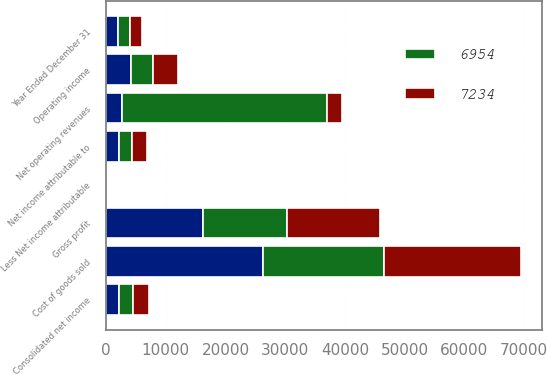Convert chart to OTSL. <chart><loc_0><loc_0><loc_500><loc_500><stacked_bar_chart><ecel><fcel>Year Ended December 31<fcel>Net operating revenues<fcel>Cost of goods sold<fcel>Gross profit<fcel>Operating income<fcel>Consolidated net income<fcel>Less Net income attributable<fcel>Net income attributable to<nl><fcel>nan<fcel>2011<fcel>2614.5<fcel>26271<fcel>16201<fcel>4181<fcel>2237<fcel>99<fcel>2138<nl><fcel>7234<fcel>2010<fcel>2614.5<fcel>23053<fcel>15610<fcel>4134<fcel>2659<fcel>89<fcel>2570<nl><fcel>6954<fcel>2009<fcel>34292<fcel>20205<fcel>14087<fcel>3657<fcel>2269<fcel>78<fcel>2191<nl></chart> 